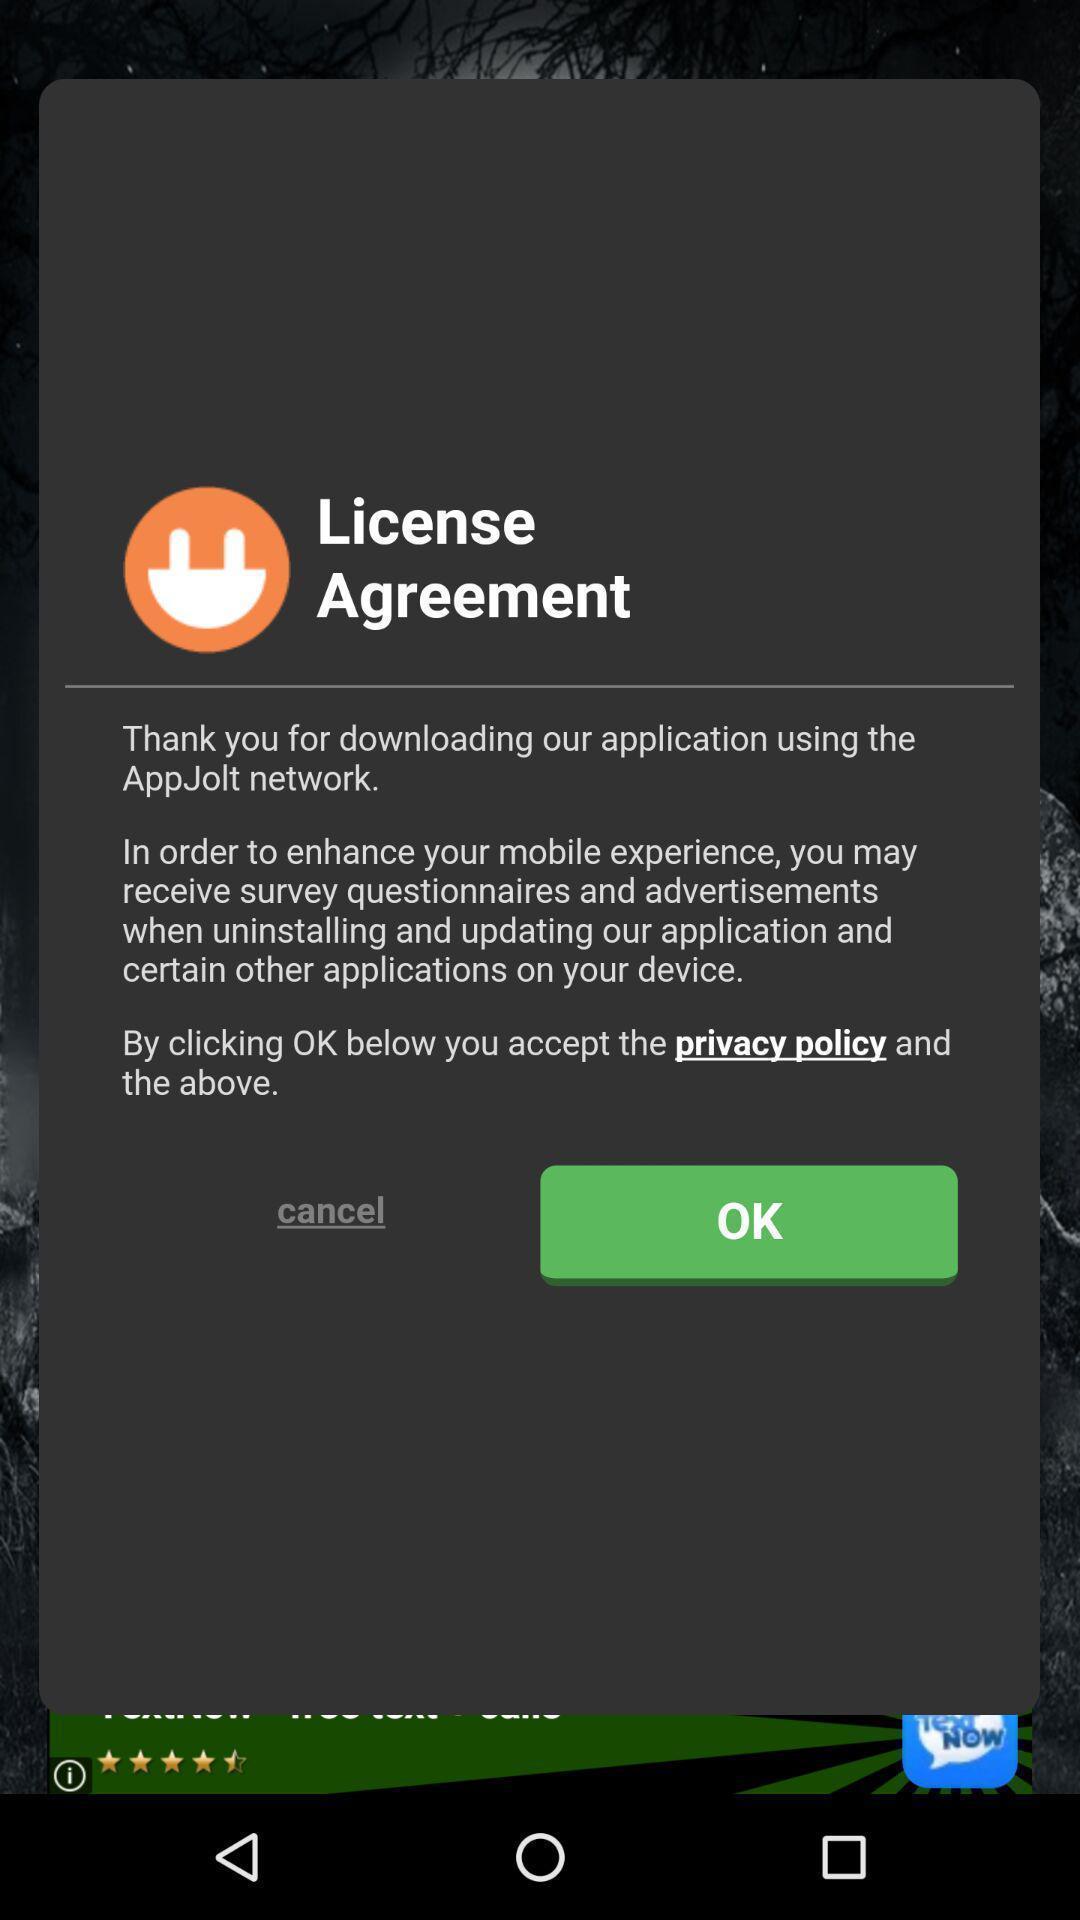Provide a textual representation of this image. Popup displaying license agreement information. 